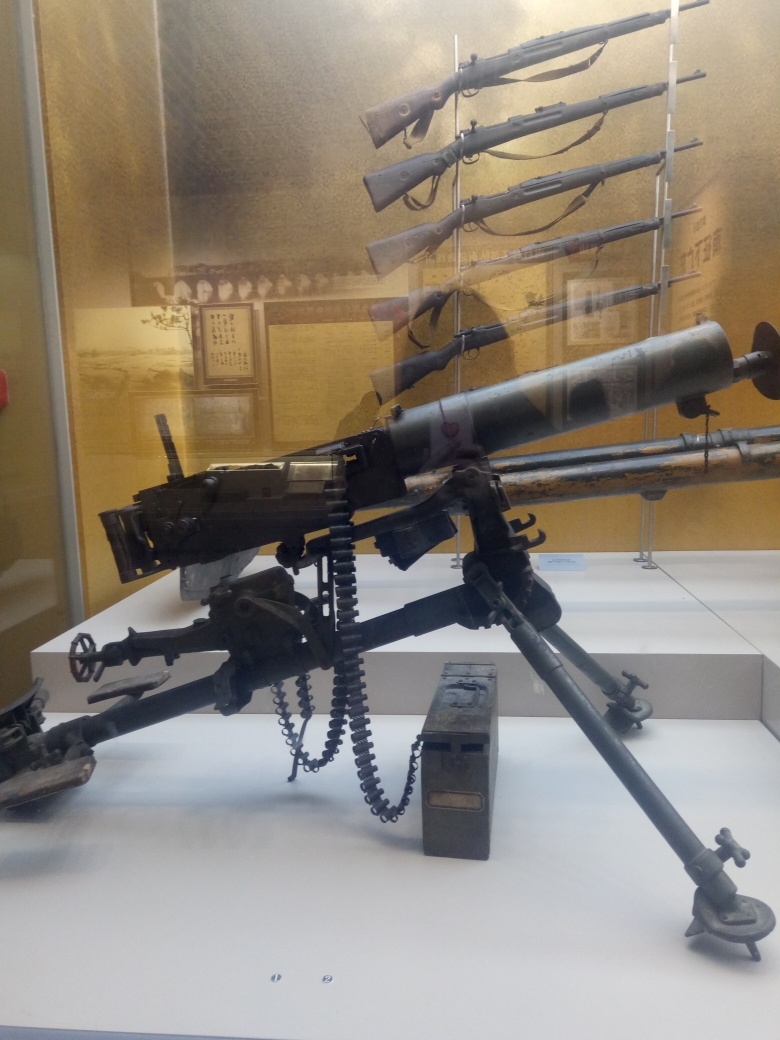Is the main subject, firearms on display, clear? Yes, the main subject of firearms on display is well-represented and visually clear in the image. The arrangement includes a prominently placed machine gun with a belt of ammunition, as well as a rack of rifles mounted in the background, providing a comprehensive view of the historical weaponry. 